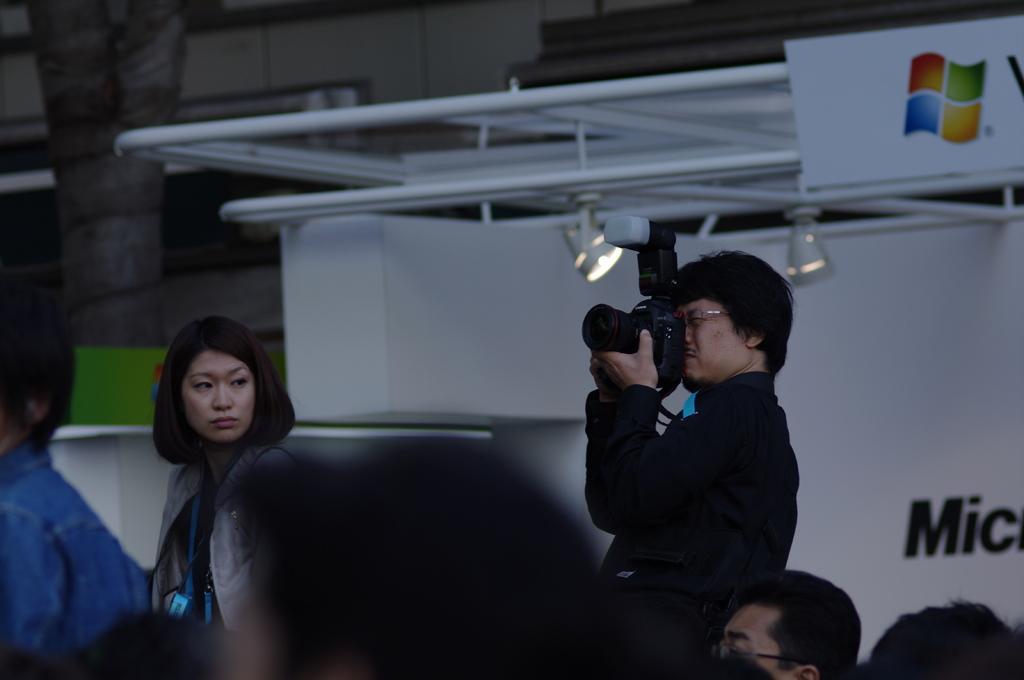Could you give a brief overview of what you see in this image? In the image we can see there are people. This Person is standing and catching a camera in his hand. This is a poster. This is a logo of a window, these are the lights. 